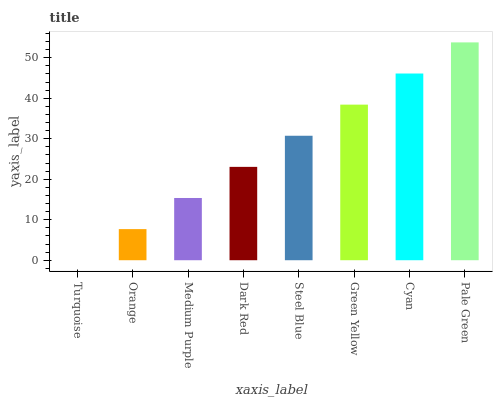Is Turquoise the minimum?
Answer yes or no. Yes. Is Pale Green the maximum?
Answer yes or no. Yes. Is Orange the minimum?
Answer yes or no. No. Is Orange the maximum?
Answer yes or no. No. Is Orange greater than Turquoise?
Answer yes or no. Yes. Is Turquoise less than Orange?
Answer yes or no. Yes. Is Turquoise greater than Orange?
Answer yes or no. No. Is Orange less than Turquoise?
Answer yes or no. No. Is Steel Blue the high median?
Answer yes or no. Yes. Is Dark Red the low median?
Answer yes or no. Yes. Is Cyan the high median?
Answer yes or no. No. Is Green Yellow the low median?
Answer yes or no. No. 